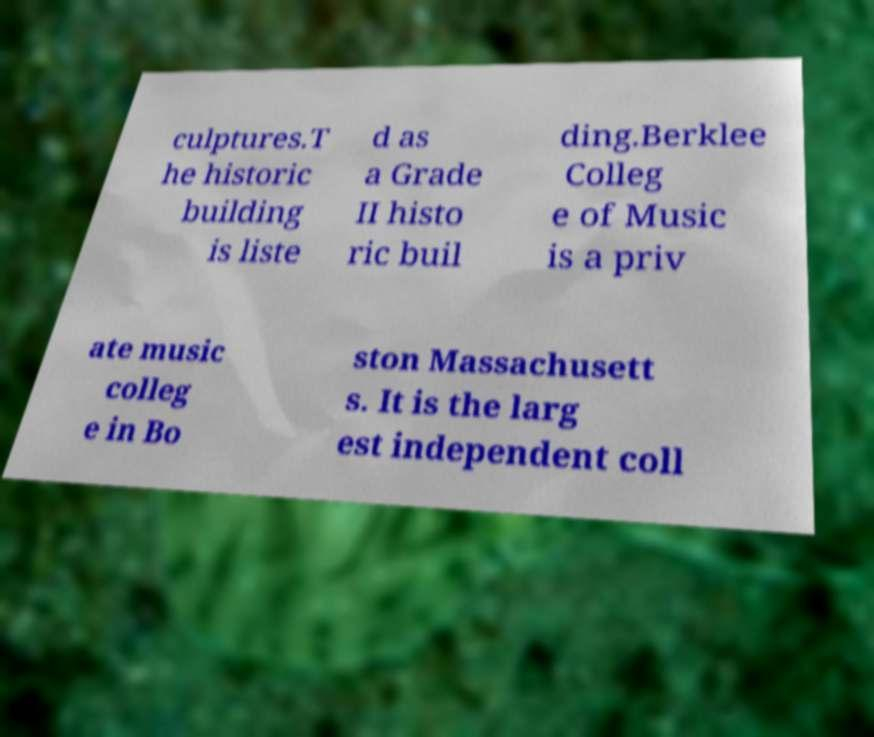What messages or text are displayed in this image? I need them in a readable, typed format. culptures.T he historic building is liste d as a Grade II histo ric buil ding.Berklee Colleg e of Music is a priv ate music colleg e in Bo ston Massachusett s. It is the larg est independent coll 